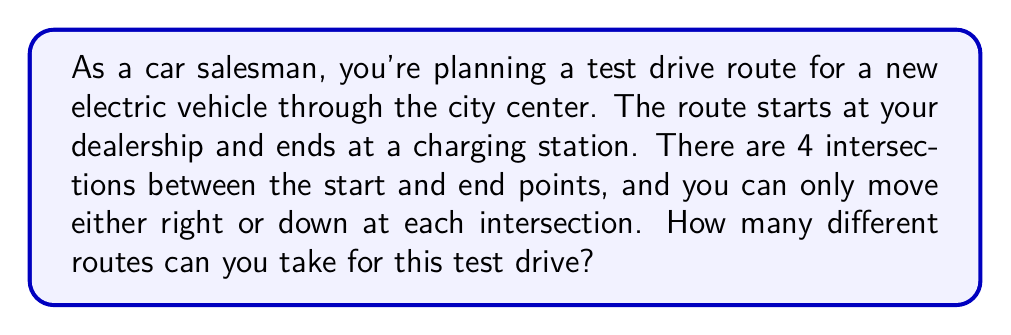Can you solve this math problem? Let's approach this step-by-step:

1) First, we need to visualize the problem. We can represent it as a grid:

   [asy]
   unitsize(1cm);
   for(int i=0; i<=4; ++i) {
     draw((0,i)--(4,i),gray);
     draw((i,0)--(i,4),gray);
   }
   label("Start", (0,4), W);
   label("End", (4,0), E);
   [/asy]

2) Notice that to get from Start to End, we always need to go 4 steps right and 4 steps down, regardless of the route.

3) This is a classic combinatorics problem. We need to choose the positions for either the right moves or the down moves.

4) We can solve this using the combination formula. We need to choose 4 positions out of 8 total moves for either right or down moves.

5) The number of ways to choose $k$ items from $n$ items is given by the combination formula:

   $${n \choose k} = \frac{n!}{k!(n-k)!}$$

6) In our case, $n = 8$ (total moves) and $k = 4$ (right moves or down moves):

   $${8 \choose 4} = \frac{8!}{4!(8-4)!} = \frac{8!}{4!4!}$$

7) Let's calculate this:
   $$\frac{8 * 7 * 6 * 5 * 4!}{4! * 4 * 3 * 2 * 1} = \frac{1680}{24} = 70$$

Therefore, there are 70 different possible routes for the test drive.
Answer: 70 